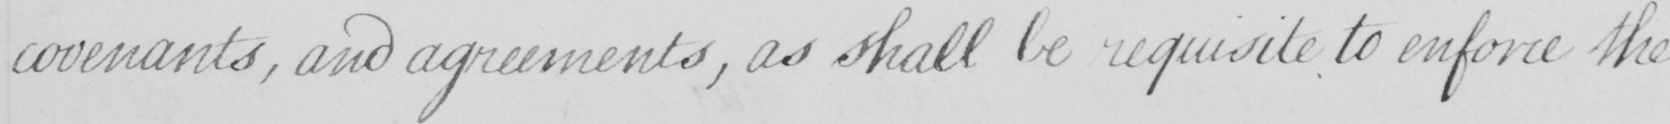Can you tell me what this handwritten text says? covenants , and agreements , as shall be requisite to enforce the 